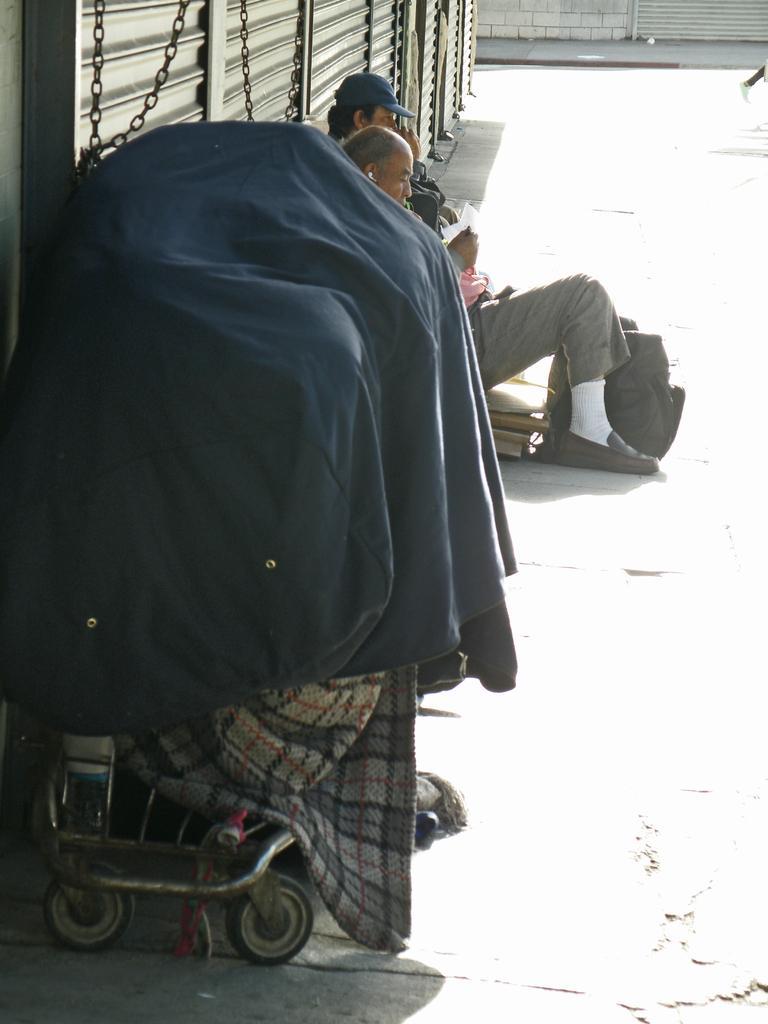Please provide a concise description of this image. In this picture I can see a cart on the left side. There are two persons in the middle, at the top there are shutters. 